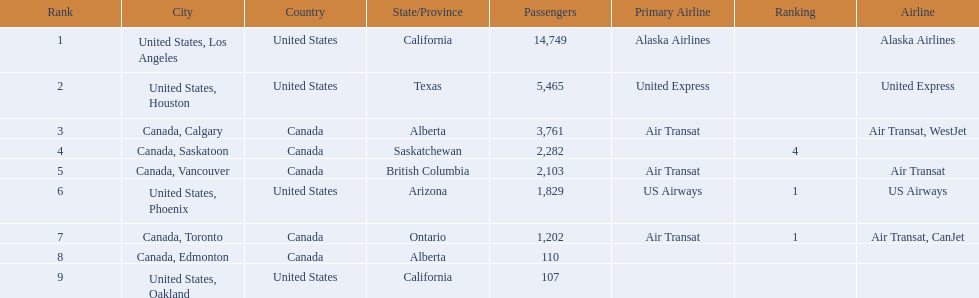What were all the passenger totals? 14,749, 5,465, 3,761, 2,282, 2,103, 1,829, 1,202, 110, 107. Which of these were to los angeles? 14,749. What other destination combined with this is closest to 19,000? Canada, Calgary. 